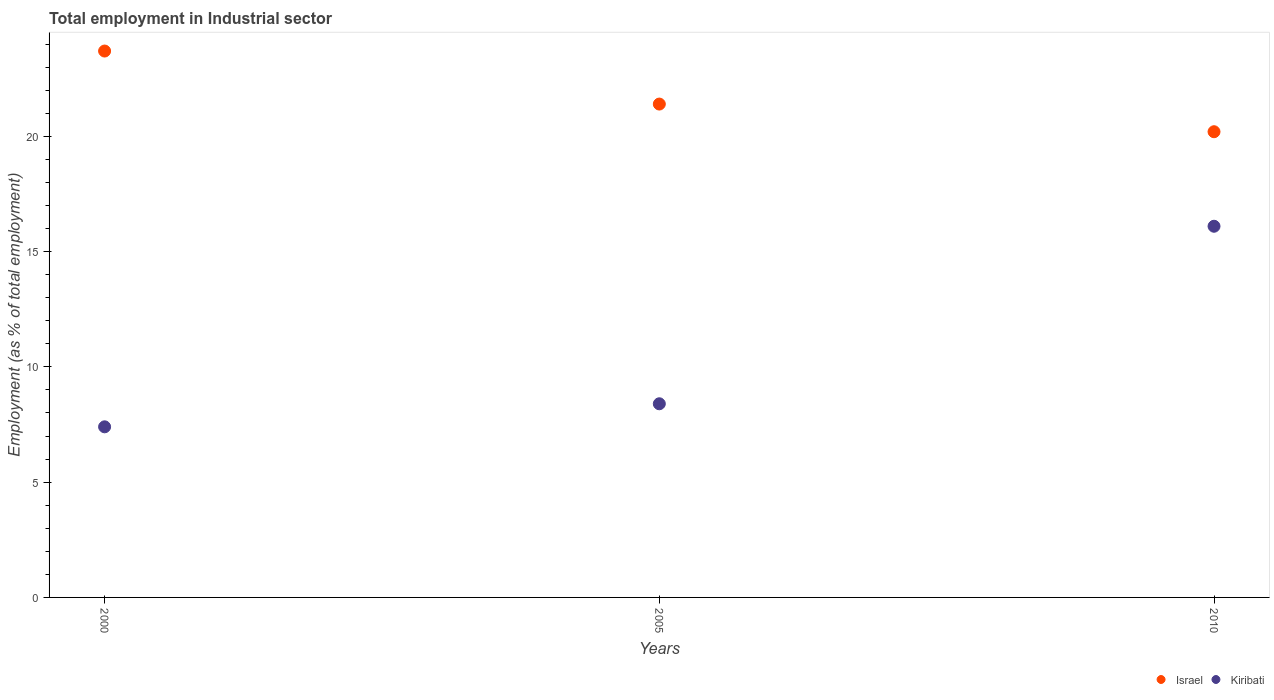How many different coloured dotlines are there?
Offer a very short reply. 2. Is the number of dotlines equal to the number of legend labels?
Offer a terse response. Yes. What is the employment in industrial sector in Kiribati in 2005?
Keep it short and to the point. 8.4. Across all years, what is the maximum employment in industrial sector in Israel?
Provide a succinct answer. 23.7. Across all years, what is the minimum employment in industrial sector in Kiribati?
Offer a very short reply. 7.4. What is the total employment in industrial sector in Kiribati in the graph?
Your answer should be compact. 31.9. What is the difference between the employment in industrial sector in Kiribati in 2000 and that in 2005?
Keep it short and to the point. -1. What is the difference between the employment in industrial sector in Israel in 2000 and the employment in industrial sector in Kiribati in 2010?
Give a very brief answer. 7.6. What is the average employment in industrial sector in Kiribati per year?
Your answer should be very brief. 10.63. In the year 2010, what is the difference between the employment in industrial sector in Kiribati and employment in industrial sector in Israel?
Provide a short and direct response. -4.1. In how many years, is the employment in industrial sector in Kiribati greater than 16 %?
Make the answer very short. 1. What is the ratio of the employment in industrial sector in Israel in 2000 to that in 2005?
Offer a very short reply. 1.11. Is the difference between the employment in industrial sector in Kiribati in 2005 and 2010 greater than the difference between the employment in industrial sector in Israel in 2005 and 2010?
Keep it short and to the point. No. What is the difference between the highest and the second highest employment in industrial sector in Israel?
Ensure brevity in your answer.  2.3. What is the difference between the highest and the lowest employment in industrial sector in Israel?
Your answer should be very brief. 3.5. In how many years, is the employment in industrial sector in Israel greater than the average employment in industrial sector in Israel taken over all years?
Ensure brevity in your answer.  1. Is the sum of the employment in industrial sector in Israel in 2005 and 2010 greater than the maximum employment in industrial sector in Kiribati across all years?
Provide a short and direct response. Yes. Does the employment in industrial sector in Kiribati monotonically increase over the years?
Your answer should be very brief. Yes. Is the employment in industrial sector in Kiribati strictly greater than the employment in industrial sector in Israel over the years?
Give a very brief answer. No. How many years are there in the graph?
Provide a succinct answer. 3. What is the difference between two consecutive major ticks on the Y-axis?
Provide a succinct answer. 5. Are the values on the major ticks of Y-axis written in scientific E-notation?
Your response must be concise. No. Does the graph contain any zero values?
Keep it short and to the point. No. Where does the legend appear in the graph?
Make the answer very short. Bottom right. What is the title of the graph?
Provide a short and direct response. Total employment in Industrial sector. Does "Kuwait" appear as one of the legend labels in the graph?
Offer a very short reply. No. What is the label or title of the Y-axis?
Your answer should be compact. Employment (as % of total employment). What is the Employment (as % of total employment) of Israel in 2000?
Your response must be concise. 23.7. What is the Employment (as % of total employment) of Kiribati in 2000?
Your answer should be very brief. 7.4. What is the Employment (as % of total employment) of Israel in 2005?
Offer a terse response. 21.4. What is the Employment (as % of total employment) in Kiribati in 2005?
Give a very brief answer. 8.4. What is the Employment (as % of total employment) in Israel in 2010?
Offer a very short reply. 20.2. What is the Employment (as % of total employment) of Kiribati in 2010?
Your answer should be very brief. 16.1. Across all years, what is the maximum Employment (as % of total employment) in Israel?
Provide a succinct answer. 23.7. Across all years, what is the maximum Employment (as % of total employment) in Kiribati?
Keep it short and to the point. 16.1. Across all years, what is the minimum Employment (as % of total employment) in Israel?
Offer a terse response. 20.2. Across all years, what is the minimum Employment (as % of total employment) in Kiribati?
Offer a very short reply. 7.4. What is the total Employment (as % of total employment) of Israel in the graph?
Give a very brief answer. 65.3. What is the total Employment (as % of total employment) in Kiribati in the graph?
Your response must be concise. 31.9. What is the difference between the Employment (as % of total employment) in Israel in 2000 and that in 2005?
Your answer should be compact. 2.3. What is the difference between the Employment (as % of total employment) in Kiribati in 2000 and that in 2005?
Provide a succinct answer. -1. What is the difference between the Employment (as % of total employment) in Israel in 2005 and the Employment (as % of total employment) in Kiribati in 2010?
Keep it short and to the point. 5.3. What is the average Employment (as % of total employment) in Israel per year?
Keep it short and to the point. 21.77. What is the average Employment (as % of total employment) of Kiribati per year?
Your answer should be very brief. 10.63. In the year 2010, what is the difference between the Employment (as % of total employment) in Israel and Employment (as % of total employment) in Kiribati?
Offer a terse response. 4.1. What is the ratio of the Employment (as % of total employment) of Israel in 2000 to that in 2005?
Provide a succinct answer. 1.11. What is the ratio of the Employment (as % of total employment) of Kiribati in 2000 to that in 2005?
Keep it short and to the point. 0.88. What is the ratio of the Employment (as % of total employment) in Israel in 2000 to that in 2010?
Provide a short and direct response. 1.17. What is the ratio of the Employment (as % of total employment) of Kiribati in 2000 to that in 2010?
Your answer should be very brief. 0.46. What is the ratio of the Employment (as % of total employment) of Israel in 2005 to that in 2010?
Offer a very short reply. 1.06. What is the ratio of the Employment (as % of total employment) of Kiribati in 2005 to that in 2010?
Your answer should be very brief. 0.52. 